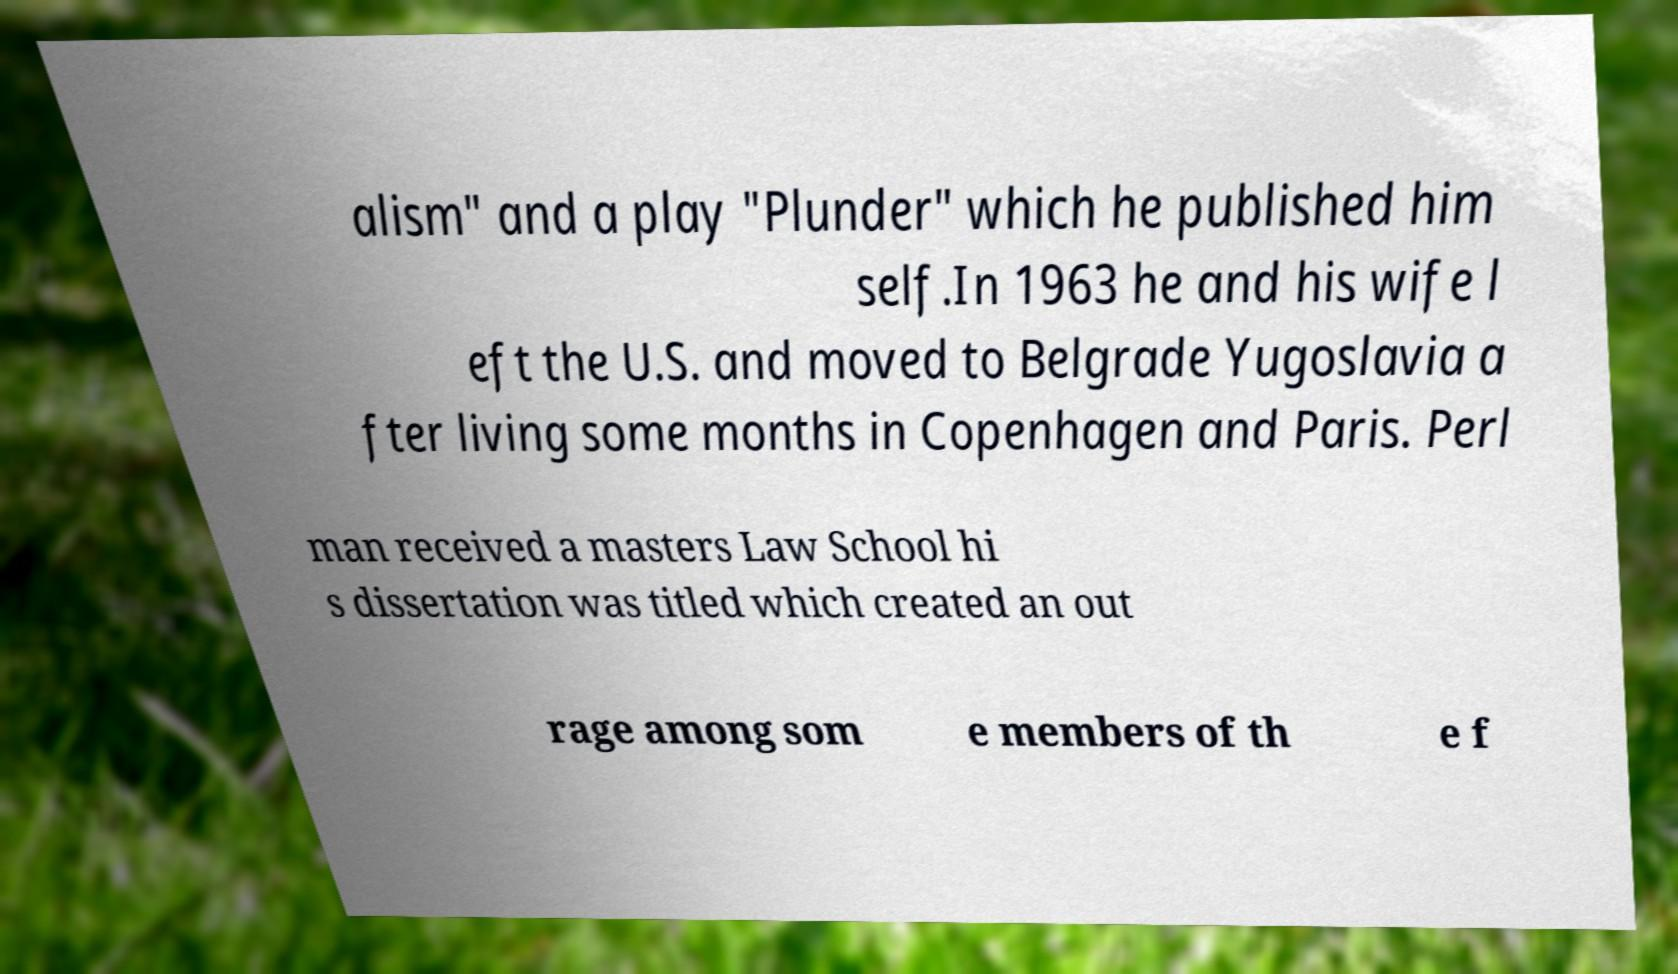Please identify and transcribe the text found in this image. alism" and a play "Plunder" which he published him self.In 1963 he and his wife l eft the U.S. and moved to Belgrade Yugoslavia a fter living some months in Copenhagen and Paris. Perl man received a masters Law School hi s dissertation was titled which created an out rage among som e members of th e f 